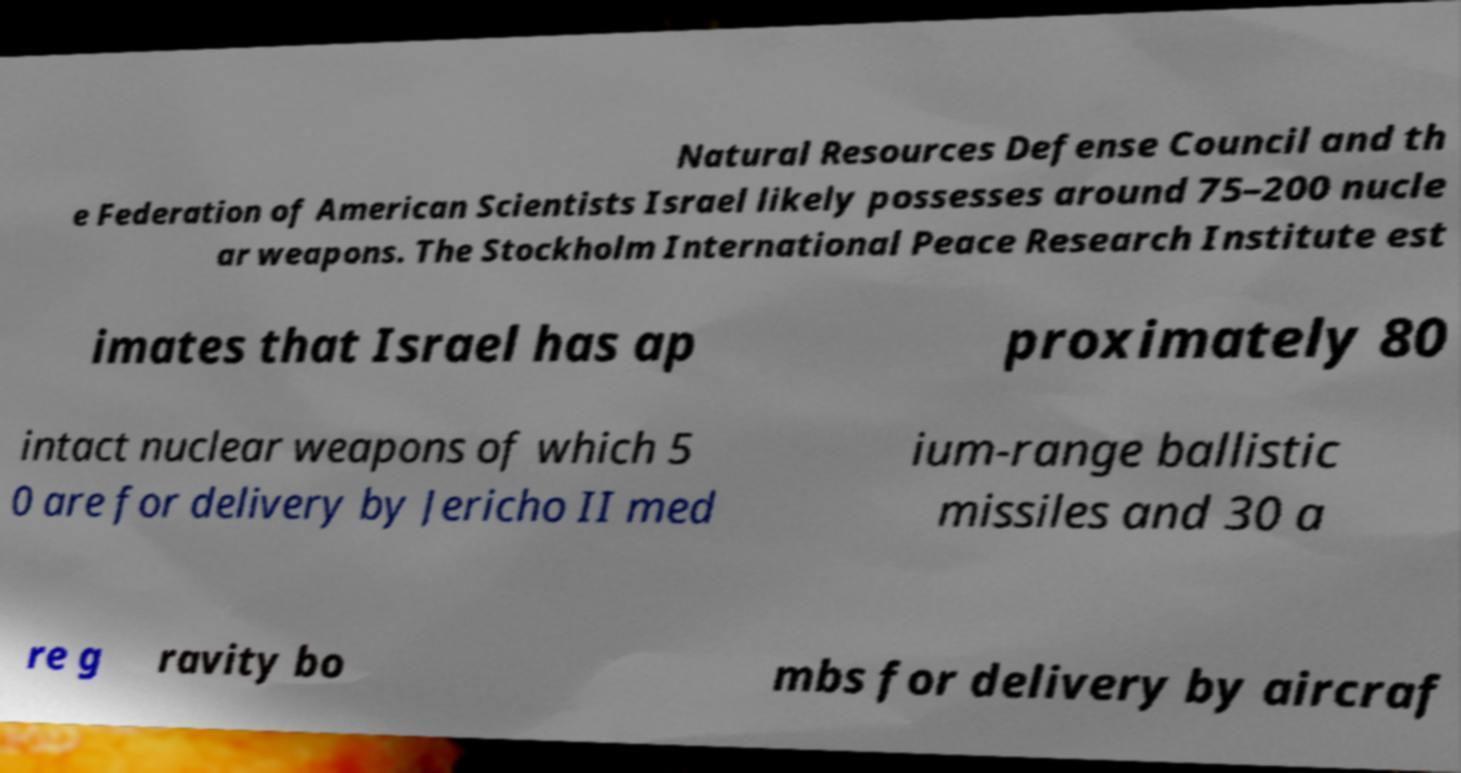Can you read and provide the text displayed in the image?This photo seems to have some interesting text. Can you extract and type it out for me? Natural Resources Defense Council and th e Federation of American Scientists Israel likely possesses around 75–200 nucle ar weapons. The Stockholm International Peace Research Institute est imates that Israel has ap proximately 80 intact nuclear weapons of which 5 0 are for delivery by Jericho II med ium-range ballistic missiles and 30 a re g ravity bo mbs for delivery by aircraf 